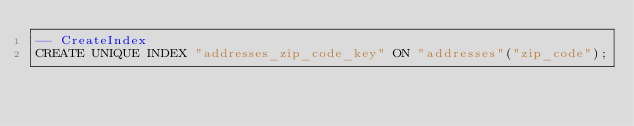Convert code to text. <code><loc_0><loc_0><loc_500><loc_500><_SQL_>-- CreateIndex
CREATE UNIQUE INDEX "addresses_zip_code_key" ON "addresses"("zip_code");
</code> 